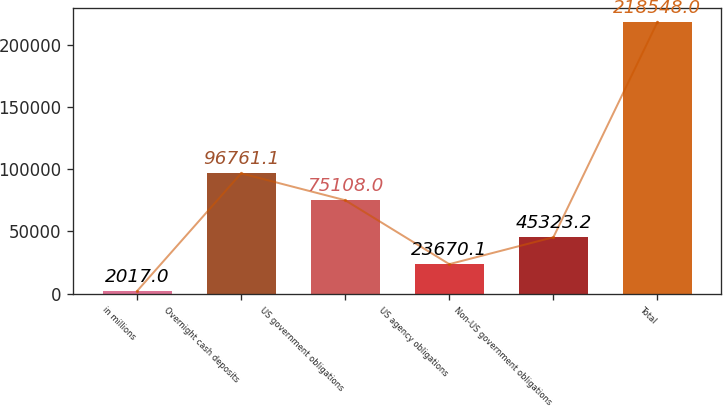Convert chart to OTSL. <chart><loc_0><loc_0><loc_500><loc_500><bar_chart><fcel>in millions<fcel>Overnight cash deposits<fcel>US government obligations<fcel>US agency obligations<fcel>Non-US government obligations<fcel>Total<nl><fcel>2017<fcel>96761.1<fcel>75108<fcel>23670.1<fcel>45323.2<fcel>218548<nl></chart> 